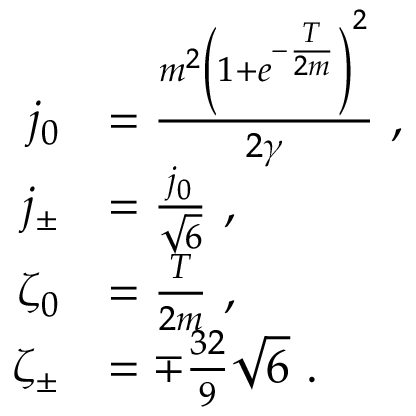<formula> <loc_0><loc_0><loc_500><loc_500>\begin{array} { r l } { j _ { 0 } } & { = \frac { m ^ { 2 } \left ( 1 + e ^ { - \frac { T } { 2 m } } \right ) ^ { 2 } } { 2 \gamma } \ , } \\ { j _ { \pm } } & { = \frac { j _ { 0 } } { \sqrt { 6 } } \ , } \\ { \zeta _ { 0 } } & { = \frac { T } { 2 m } \ , } \\ { \zeta _ { \pm } } & { = \mp \frac { 3 2 } { 9 } \sqrt { 6 } \ . } \end{array}</formula> 